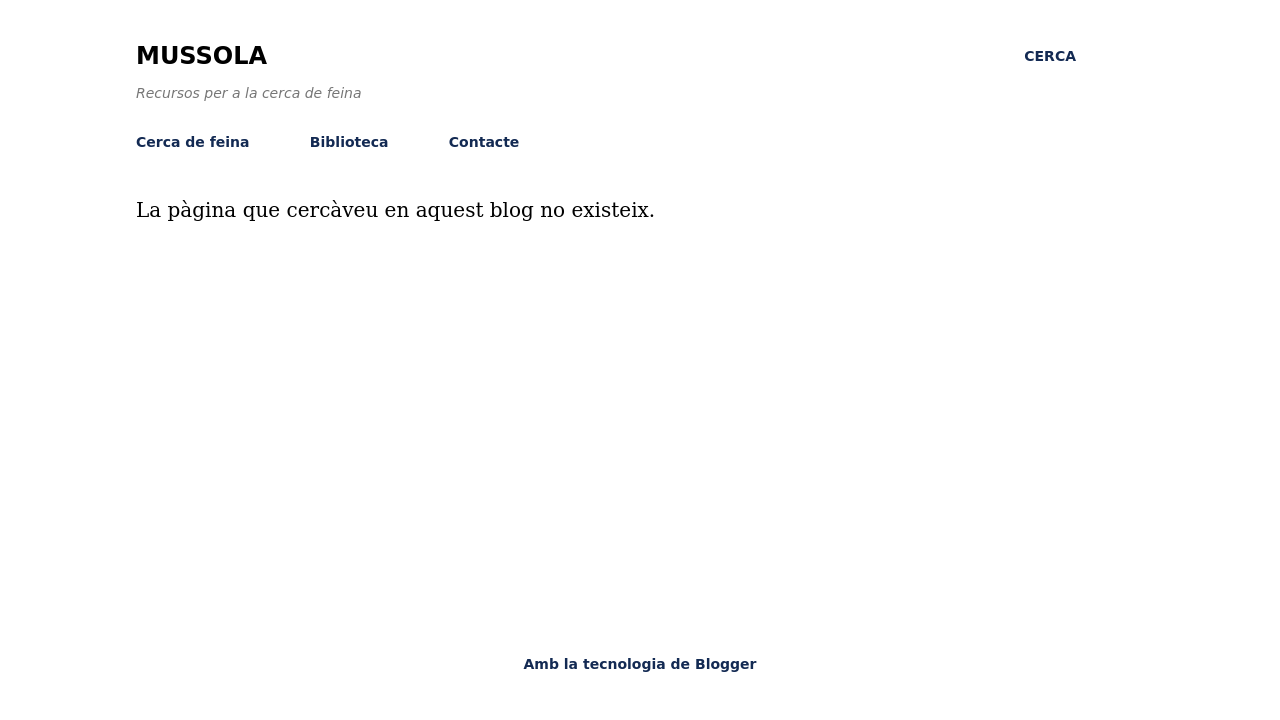What improvements could be made to the website's error page displayed in the image? Improving the error page shown in the image could involve several enhancements. First, adding more detailed information about why the page couldn't be found and possible next steps could guide users more effectively. You could also include a search bar directly on the error page to help users find what they're looking for without navigating away. Lastly, enriching the design with some engaging graphics or a friendly error message could make the page feel less disappointing and more helpful. 